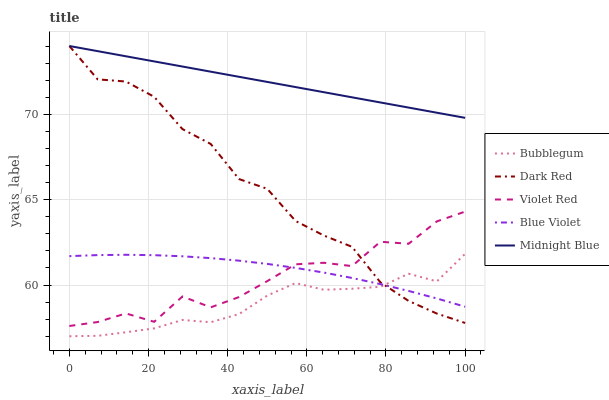Does Bubblegum have the minimum area under the curve?
Answer yes or no. Yes. Does Midnight Blue have the maximum area under the curve?
Answer yes or no. Yes. Does Violet Red have the minimum area under the curve?
Answer yes or no. No. Does Violet Red have the maximum area under the curve?
Answer yes or no. No. Is Midnight Blue the smoothest?
Answer yes or no. Yes. Is Violet Red the roughest?
Answer yes or no. Yes. Is Blue Violet the smoothest?
Answer yes or no. No. Is Blue Violet the roughest?
Answer yes or no. No. Does Bubblegum have the lowest value?
Answer yes or no. Yes. Does Violet Red have the lowest value?
Answer yes or no. No. Does Midnight Blue have the highest value?
Answer yes or no. Yes. Does Violet Red have the highest value?
Answer yes or no. No. Is Bubblegum less than Midnight Blue?
Answer yes or no. Yes. Is Midnight Blue greater than Blue Violet?
Answer yes or no. Yes. Does Dark Red intersect Violet Red?
Answer yes or no. Yes. Is Dark Red less than Violet Red?
Answer yes or no. No. Is Dark Red greater than Violet Red?
Answer yes or no. No. Does Bubblegum intersect Midnight Blue?
Answer yes or no. No. 